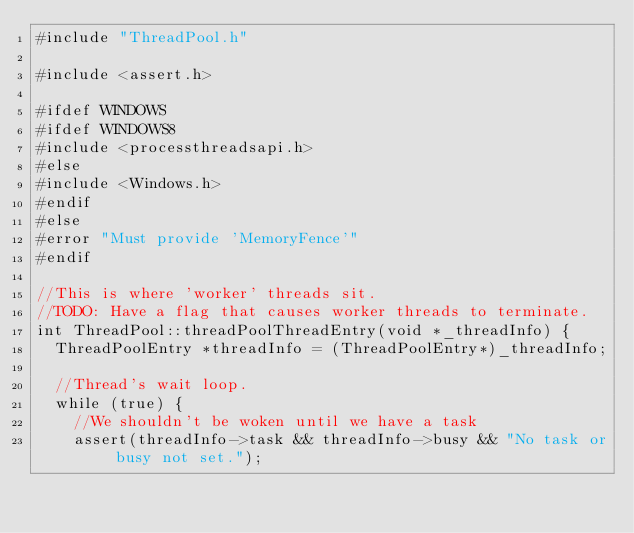Convert code to text. <code><loc_0><loc_0><loc_500><loc_500><_C++_>#include "ThreadPool.h"

#include <assert.h>

#ifdef WINDOWS
#ifdef WINDOWS8
#include <processthreadsapi.h>
#else
#include <Windows.h>
#endif
#else
#error "Must provide 'MemoryFence'"
#endif

//This is where 'worker' threads sit.
//TODO: Have a flag that causes worker threads to terminate.
int ThreadPool::threadPoolThreadEntry(void *_threadInfo) {
	ThreadPoolEntry *threadInfo = (ThreadPoolEntry*)_threadInfo;

	//Thread's wait loop.
	while (true) {
		//We shouldn't be woken until we have a task
		assert(threadInfo->task && threadInfo->busy && "No task or busy not set.");</code> 